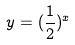Convert formula to latex. <formula><loc_0><loc_0><loc_500><loc_500>y = ( \frac { 1 } { 2 } ) ^ { x }</formula> 